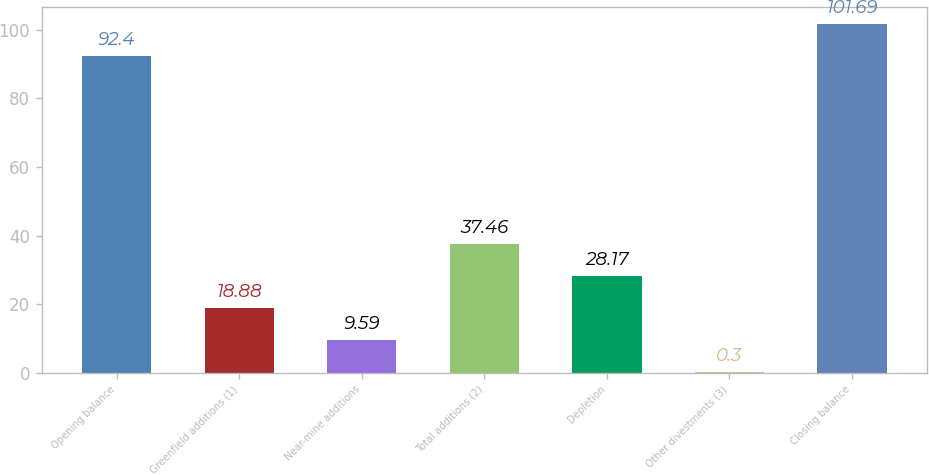Convert chart to OTSL. <chart><loc_0><loc_0><loc_500><loc_500><bar_chart><fcel>Opening balance<fcel>Greenfield additions (1)<fcel>Near-mine additions<fcel>Total additions (2)<fcel>Depletion<fcel>Other divestments (3)<fcel>Closing balance<nl><fcel>92.4<fcel>18.88<fcel>9.59<fcel>37.46<fcel>28.17<fcel>0.3<fcel>101.69<nl></chart> 